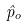Convert formula to latex. <formula><loc_0><loc_0><loc_500><loc_500>\hat { p } _ { o }</formula> 